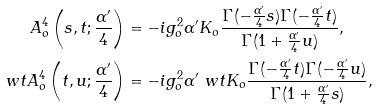<formula> <loc_0><loc_0><loc_500><loc_500>A _ { o } ^ { 4 } \left ( s , t ; \frac { \alpha ^ { \prime } } 4 \right ) & = - i g _ { o } ^ { 2 } \alpha ^ { \prime } K _ { o } \frac { \Gamma ( - \frac { \alpha ^ { \prime } } 4 s ) \Gamma ( - \frac { \alpha ^ { \prime } } 4 t ) } { \Gamma ( 1 + \frac { \alpha ^ { \prime } } 4 u ) } , \\ \ w t { A } _ { o } ^ { 4 } \left ( t , u ; \frac { \alpha ^ { \prime } } 4 \right ) & = - i g _ { o } ^ { 2 } \alpha ^ { \prime } \ w t { K } _ { o } \frac { \Gamma ( - \frac { \alpha ^ { \prime } } 4 t ) \Gamma ( - \frac { \alpha ^ { \prime } } 4 u ) } { \Gamma ( 1 + \frac { \alpha ^ { \prime } } 4 s ) } ,</formula> 